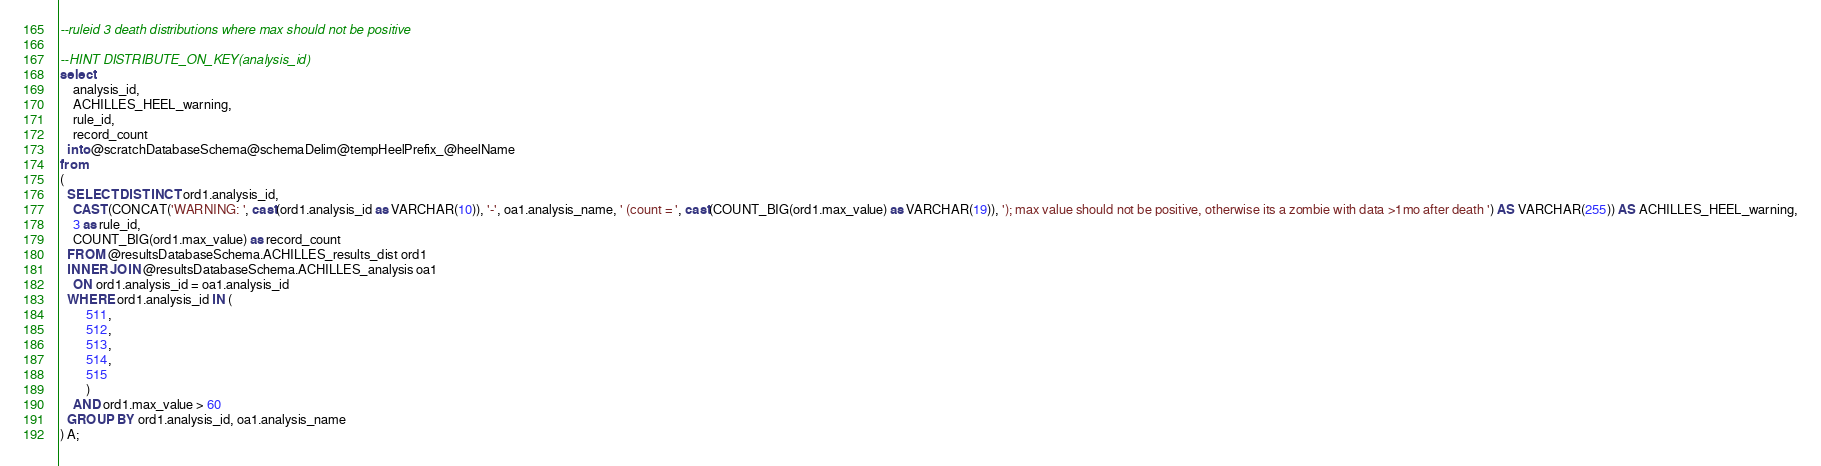<code> <loc_0><loc_0><loc_500><loc_500><_SQL_>--ruleid 3 death distributions where max should not be positive

--HINT DISTRIBUTE_ON_KEY(analysis_id)
select
	analysis_id,
	ACHILLES_HEEL_warning,
	rule_id,
	record_count
  into @scratchDatabaseSchema@schemaDelim@tempHeelPrefix_@heelName
from
(
  SELECT DISTINCT ord1.analysis_id,
    CAST(CONCAT('WARNING: ', cast(ord1.analysis_id as VARCHAR(10)), '-', oa1.analysis_name, ' (count = ', cast(COUNT_BIG(ord1.max_value) as VARCHAR(19)), '); max value should not be positive, otherwise its a zombie with data >1mo after death ') AS VARCHAR(255)) AS ACHILLES_HEEL_warning,
    3 as rule_id,
    COUNT_BIG(ord1.max_value) as record_count
  FROM @resultsDatabaseSchema.ACHILLES_results_dist ord1
  INNER JOIN @resultsDatabaseSchema.ACHILLES_analysis oa1
  	ON ord1.analysis_id = oa1.analysis_id
  WHERE ord1.analysis_id IN (
  		511,
  		512,
  		513,
  		514,
  		515
  		)
  	AND ord1.max_value > 60
  GROUP BY ord1.analysis_id, oa1.analysis_name
) A;
</code> 